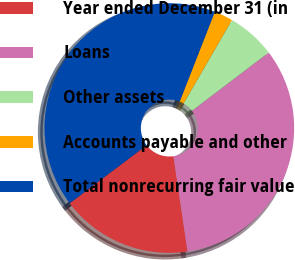<chart> <loc_0><loc_0><loc_500><loc_500><pie_chart><fcel>Year ended December 31 (in<fcel>Loans<fcel>Other assets<fcel>Accounts payable and other<fcel>Total nonrecurring fair value<nl><fcel>17.05%<fcel>33.0%<fcel>6.3%<fcel>2.42%<fcel>41.23%<nl></chart> 